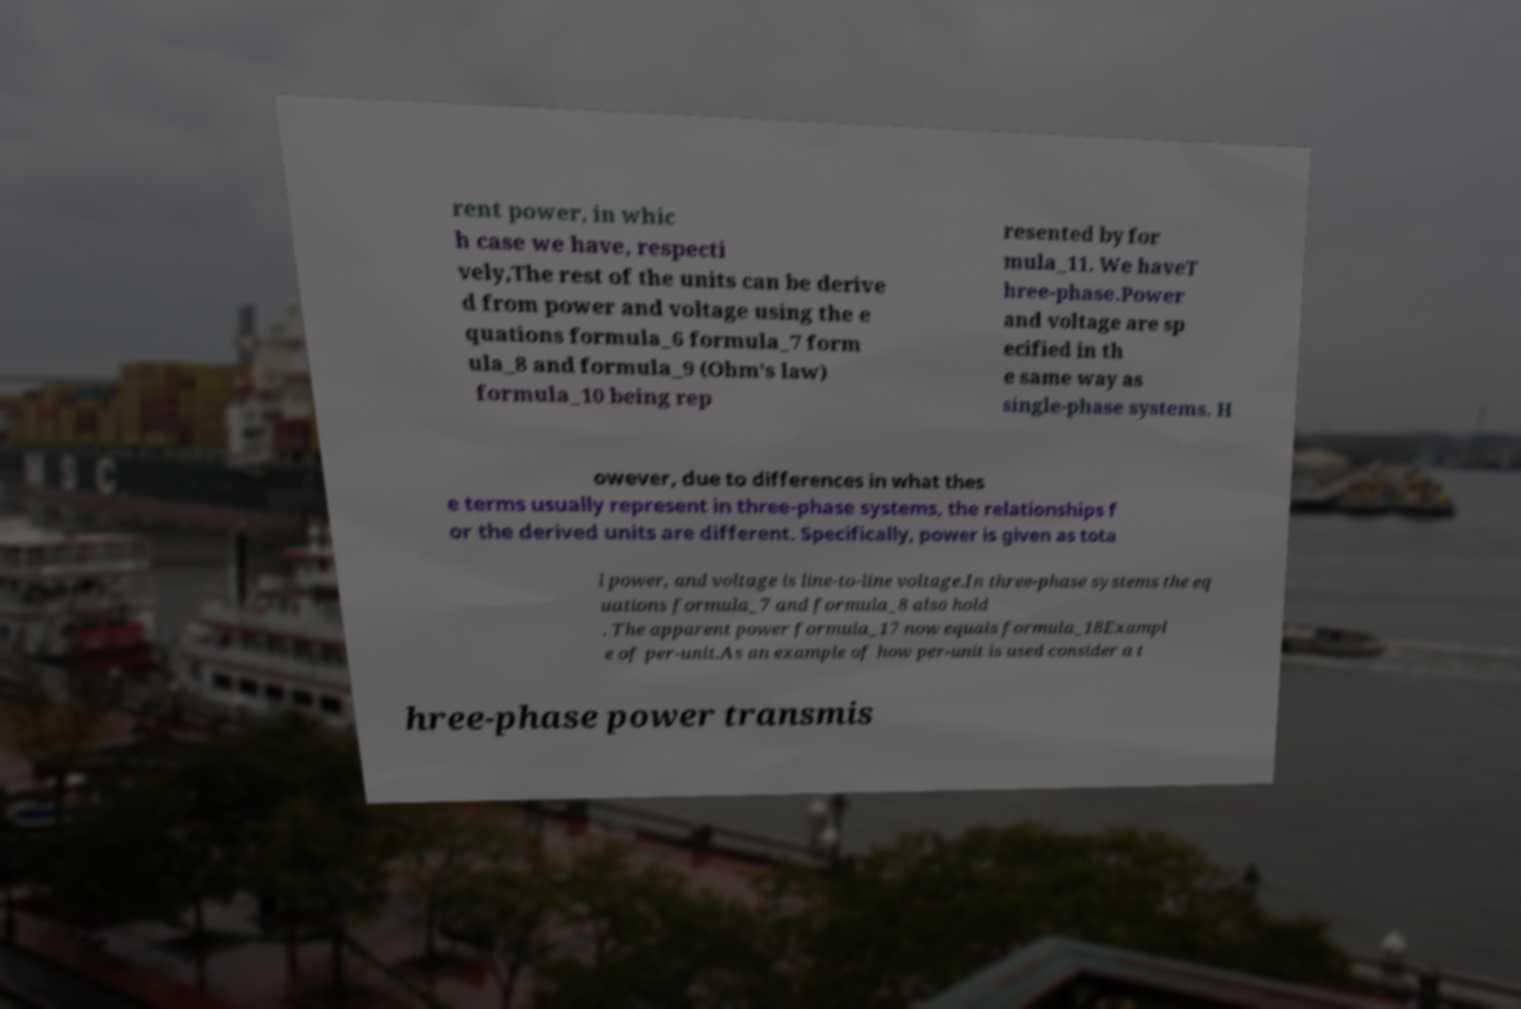Could you extract and type out the text from this image? rent power, in whic h case we have, respecti vely,The rest of the units can be derive d from power and voltage using the e quations formula_6 formula_7 form ula_8 and formula_9 (Ohm's law) formula_10 being rep resented by for mula_11. We haveT hree-phase.Power and voltage are sp ecified in th e same way as single-phase systems. H owever, due to differences in what thes e terms usually represent in three-phase systems, the relationships f or the derived units are different. Specifically, power is given as tota l power, and voltage is line-to-line voltage.In three-phase systems the eq uations formula_7 and formula_8 also hold . The apparent power formula_17 now equals formula_18Exampl e of per-unit.As an example of how per-unit is used consider a t hree-phase power transmis 